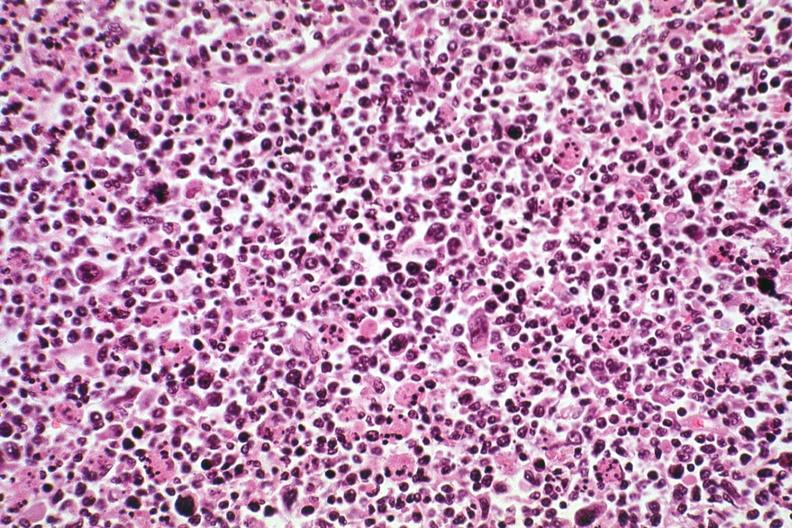s lymphoma present?
Answer the question using a single word or phrase. Yes 